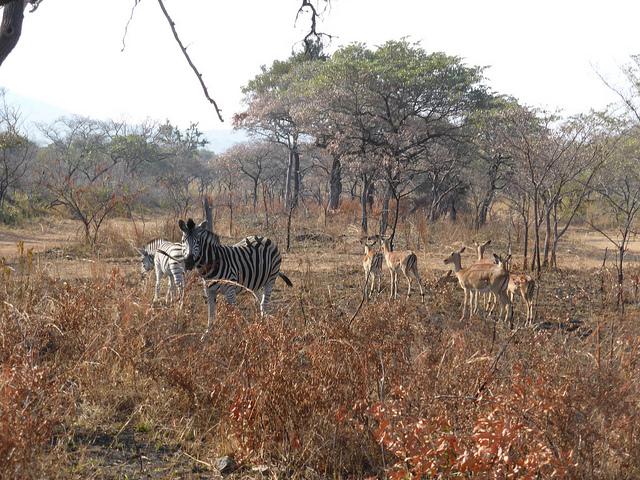Besides zebras what other animal is seen?
Answer briefly. Deer. How many zebras are there?
Short answer required. 2. Is this in the wild?
Answer briefly. Yes. 